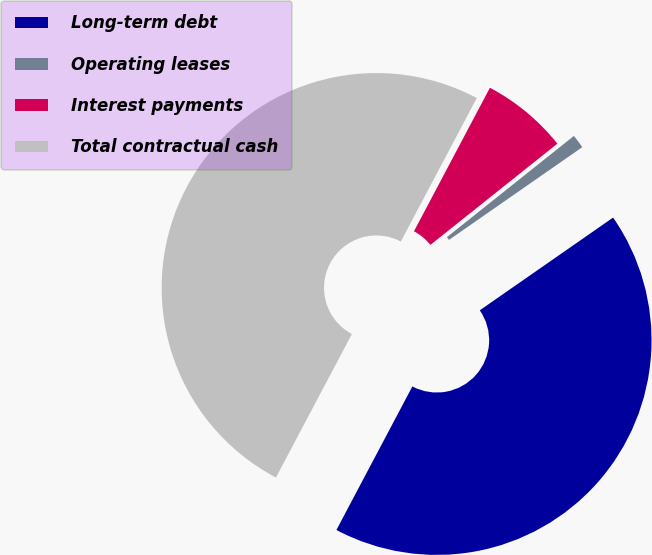Convert chart to OTSL. <chart><loc_0><loc_0><loc_500><loc_500><pie_chart><fcel>Long-term debt<fcel>Operating leases<fcel>Interest payments<fcel>Total contractual cash<nl><fcel>42.42%<fcel>1.04%<fcel>6.54%<fcel>50.0%<nl></chart> 